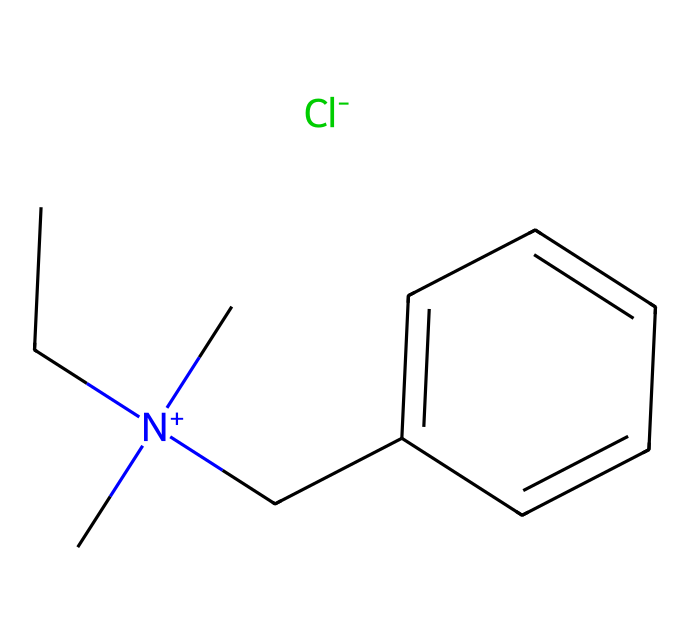What is the common name of the chemical represented by the SMILES? The SMILES notation corresponds to a quaternary ammonium compound. In common terminology, this compound is known as benzalkonium chloride.
Answer: benzalkonium chloride How many carbon atoms are in the chemical structure? By analyzing the SMILES representation, we can count the number of carbon atoms present, which includes the carbon atoms in the alkyl chain and the benzene ring. There are a total of 10 carbon atoms.
Answer: 10 What type of chemical bond is predominantly found in this compound? The primary interactions in this compound involve ionic and covalent bonds. The nitrogen atom is positively charged and forms ionic bonds with the chloride ion, while the carbon atoms are connected by covalent bonds.
Answer: ionic and covalent What is the charge of the nitrogen atom in this chemical? The nitrogen atom in the structure is represented with a positive charge due to the presence of four substituents around it, which gives it a cationic character.
Answer: positive How does this chemical function as a surfactant? Benzalkonium chloride has a hydrophobic alkyl chain and a hydrophilic quaternary ammonium head, allowing it to reduce surface tension and interact with various surfaces and contaminants, promoting the cleaning process.
Answer: surfactant What is the primary application of benzalkonium chloride in the context of audio equipment? This chemical is primarily used as a disinfectant to clean and sanitize microphones and audio equipment, ensuring they are safe and free from bacteria and viruses, which is essential in an environment where sound quality and hygiene are critical.
Answer: disinfectant 